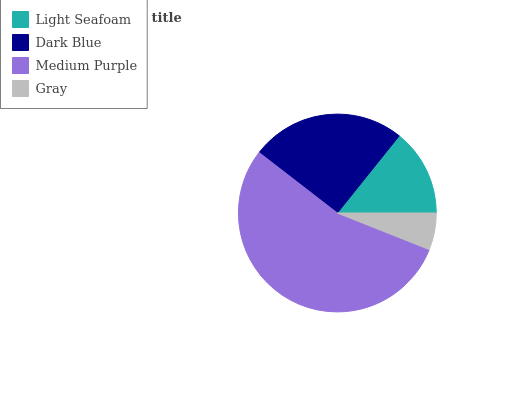Is Gray the minimum?
Answer yes or no. Yes. Is Medium Purple the maximum?
Answer yes or no. Yes. Is Dark Blue the minimum?
Answer yes or no. No. Is Dark Blue the maximum?
Answer yes or no. No. Is Dark Blue greater than Light Seafoam?
Answer yes or no. Yes. Is Light Seafoam less than Dark Blue?
Answer yes or no. Yes. Is Light Seafoam greater than Dark Blue?
Answer yes or no. No. Is Dark Blue less than Light Seafoam?
Answer yes or no. No. Is Dark Blue the high median?
Answer yes or no. Yes. Is Light Seafoam the low median?
Answer yes or no. Yes. Is Medium Purple the high median?
Answer yes or no. No. Is Medium Purple the low median?
Answer yes or no. No. 